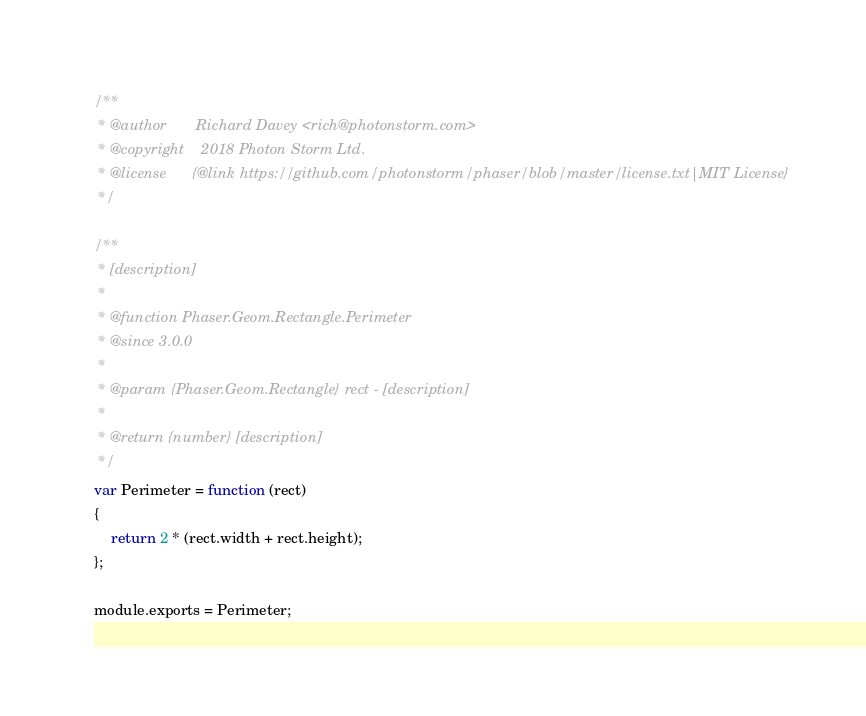Convert code to text. <code><loc_0><loc_0><loc_500><loc_500><_JavaScript_>/**
 * @author       Richard Davey <rich@photonstorm.com>
 * @copyright    2018 Photon Storm Ltd.
 * @license      {@link https://github.com/photonstorm/phaser/blob/master/license.txt|MIT License}
 */

/**
 * [description]
 *
 * @function Phaser.Geom.Rectangle.Perimeter
 * @since 3.0.0
 *
 * @param {Phaser.Geom.Rectangle} rect - [description]
 *
 * @return {number} [description]
 */
var Perimeter = function (rect)
{
    return 2 * (rect.width + rect.height);
};

module.exports = Perimeter;
</code> 